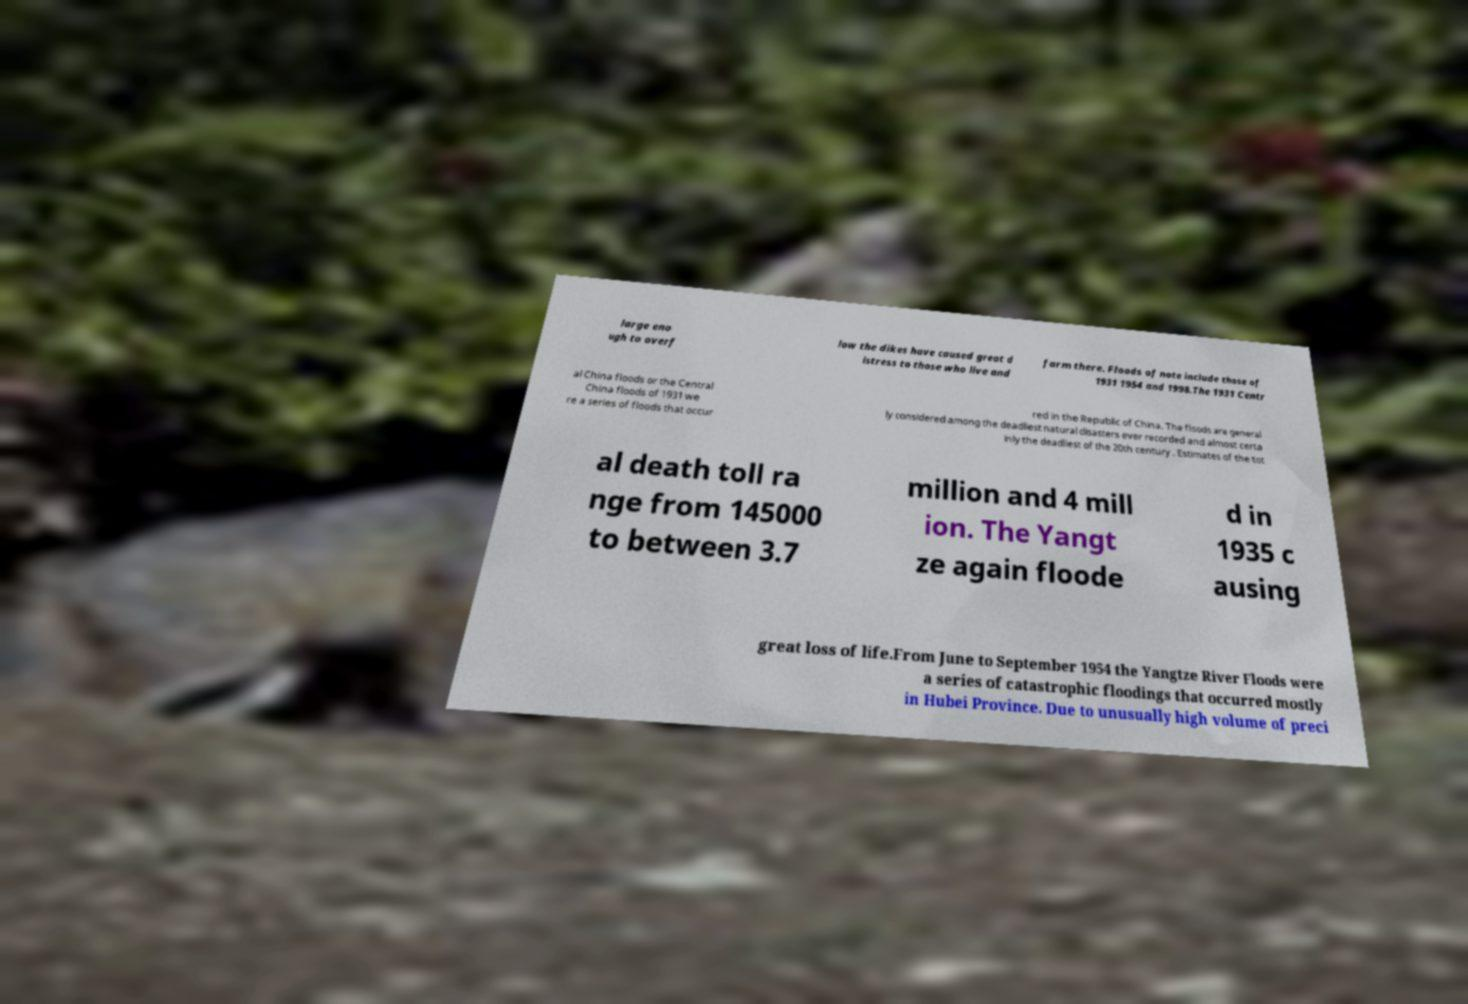Could you assist in decoding the text presented in this image and type it out clearly? large eno ugh to overf low the dikes have caused great d istress to those who live and farm there. Floods of note include those of 1931 1954 and 1998.The 1931 Centr al China floods or the Central China floods of 1931 we re a series of floods that occur red in the Republic of China. The floods are general ly considered among the deadliest natural disasters ever recorded and almost certa inly the deadliest of the 20th century . Estimates of the tot al death toll ra nge from 145000 to between 3.7 million and 4 mill ion. The Yangt ze again floode d in 1935 c ausing great loss of life.From June to September 1954 the Yangtze River Floods were a series of catastrophic floodings that occurred mostly in Hubei Province. Due to unusually high volume of preci 